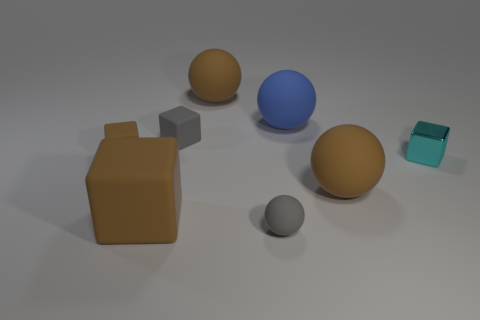Subtract 1 blocks. How many blocks are left? 3 Subtract all large rubber balls. How many balls are left? 1 Subtract all green cylinders. How many brown blocks are left? 2 Subtract all gray blocks. How many blocks are left? 3 Subtract all yellow cubes. Subtract all green cylinders. How many cubes are left? 4 Add 2 big blue cubes. How many objects exist? 10 Subtract 1 blue spheres. How many objects are left? 7 Subtract all tiny spheres. Subtract all big matte cubes. How many objects are left? 6 Add 4 small spheres. How many small spheres are left? 5 Add 7 small red metal cubes. How many small red metal cubes exist? 7 